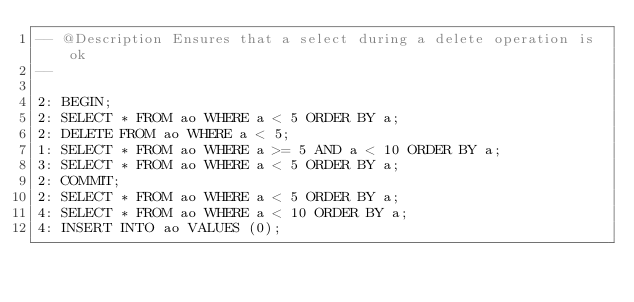Convert code to text. <code><loc_0><loc_0><loc_500><loc_500><_SQL_>-- @Description Ensures that a select during a delete operation is ok
-- 

2: BEGIN;
2: SELECT * FROM ao WHERE a < 5 ORDER BY a;
2: DELETE FROM ao WHERE a < 5;
1: SELECT * FROM ao WHERE a >= 5 AND a < 10 ORDER BY a;
3: SELECT * FROM ao WHERE a < 5 ORDER BY a;
2: COMMIT;
2: SELECT * FROM ao WHERE a < 5 ORDER BY a;
4: SELECT * FROM ao WHERE a < 10 ORDER BY a;
4: INSERT INTO ao VALUES (0);
</code> 